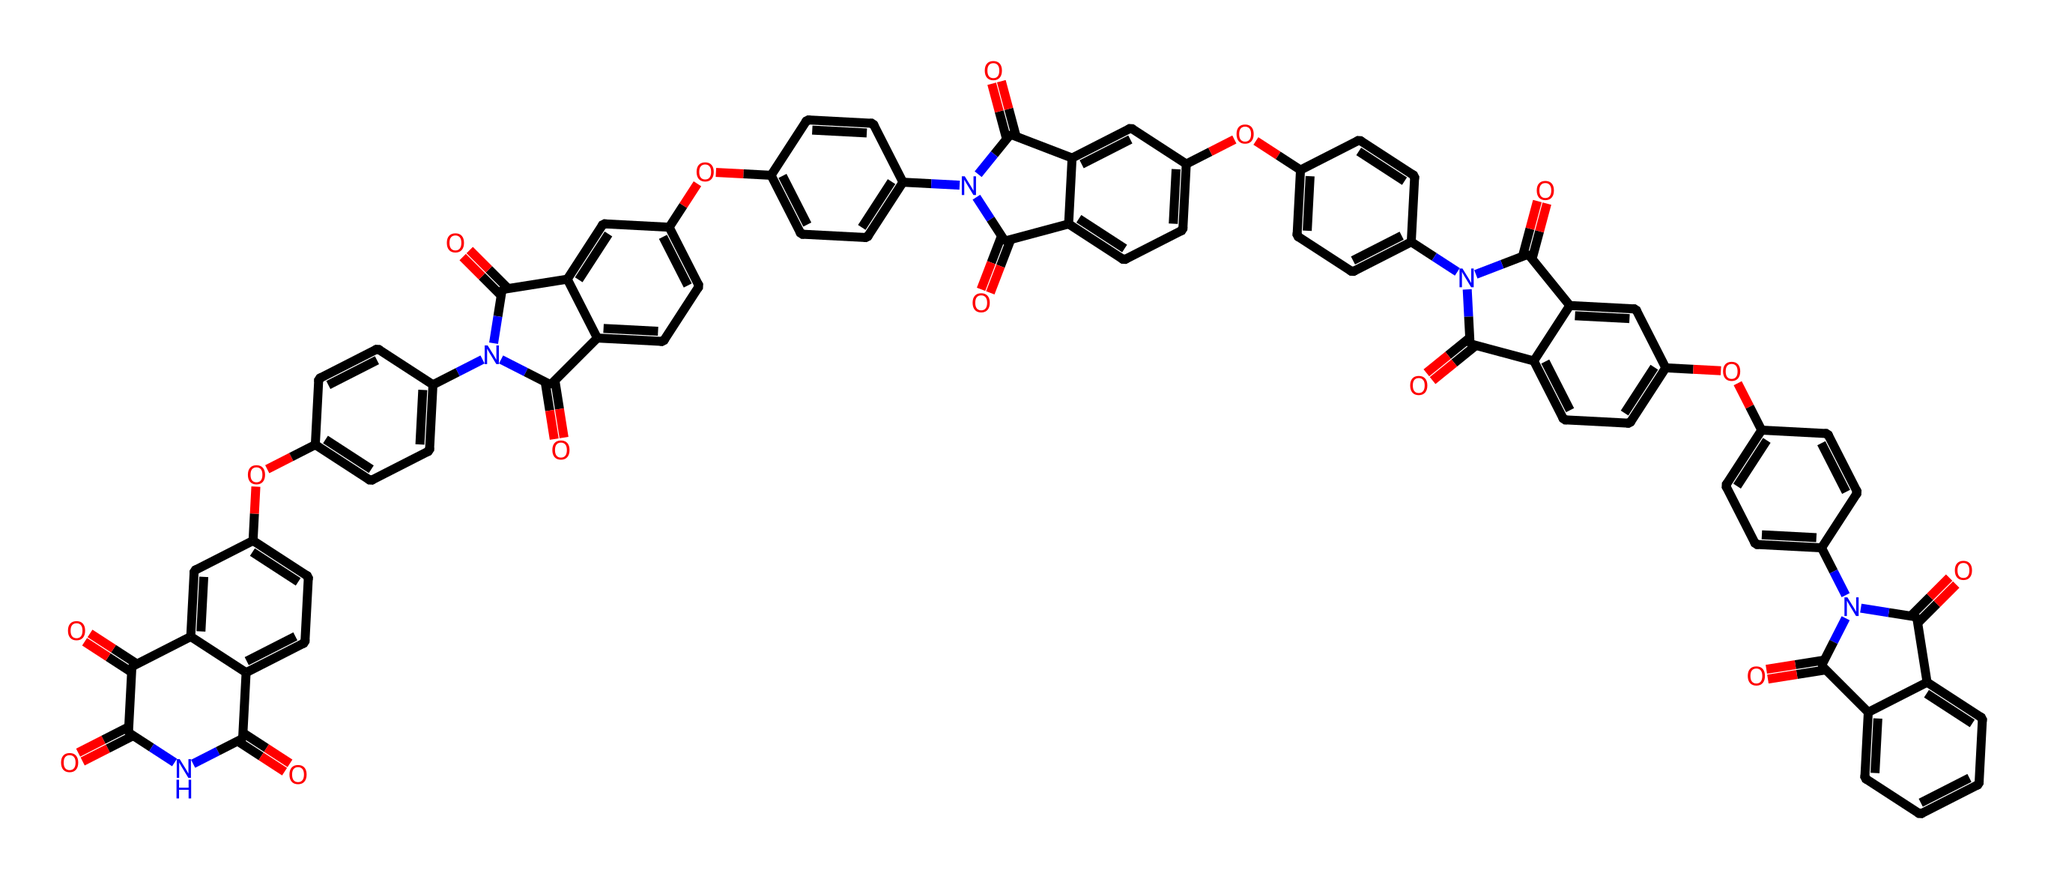What is the molecular formula of the compound? To determine the molecular formula, count the number of each type of atom represented in the chemical structure. By analyzing the SMILES, we find that there are 36 carbon atoms (C), 24 hydrogen atoms (H), 8 nitrogen atoms (N), and 8 oxygen atoms (O). Putting this together, the molecular formula is C36H24N8O8.
Answer: C36H24N8O8 How many rings are present in the structure? Analyzing the depicted structure in the SMILES, we identify several cyclic components. Each 'C1', 'C2', etc., denotes the start and conclusion of a ring. By careful inspection, we count a total of 5 distinct rings in the structure.
Answer: 5 What type of functional groups are predominant in this polyimide? Observing the structure, we see the presence of imide functional groups, denoted by the nitrogen atoms involved in carbonyls (C=O) next to them. The inclusion of multiple carbonyl groups adjacent to nitrogen atoms highlights that imides are the predominant functional groups in this polyimide material.
Answer: imide What is the significance of nitrogen atoms in this component? The nitrogen atoms in this structure indicate the presence of imide bonds, which contribute to the rigid and thermally stable nature of polyimides. This rigidity is essential for applications like film reel containers, where durability is key.
Answer: thermal stability Is this compound likely to be soluble in polar or nonpolar solvents? Considering the presence of polar functional groups, particularly the imides and carbonyls, this compound is likely more soluble in polar solvents due to the interactions these groups can make with polar solvent molecules.
Answer: polar solvents 